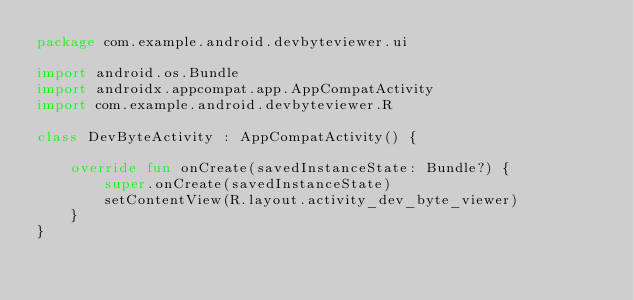Convert code to text. <code><loc_0><loc_0><loc_500><loc_500><_Kotlin_>package com.example.android.devbyteviewer.ui

import android.os.Bundle
import androidx.appcompat.app.AppCompatActivity
import com.example.android.devbyteviewer.R

class DevByteActivity : AppCompatActivity() {

    override fun onCreate(savedInstanceState: Bundle?) {
        super.onCreate(savedInstanceState)
        setContentView(R.layout.activity_dev_byte_viewer)
    }
}
</code> 